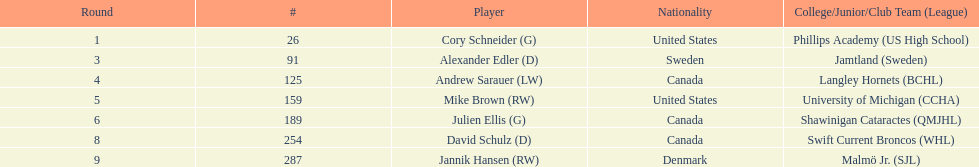How many canadian players are listed? 3. 